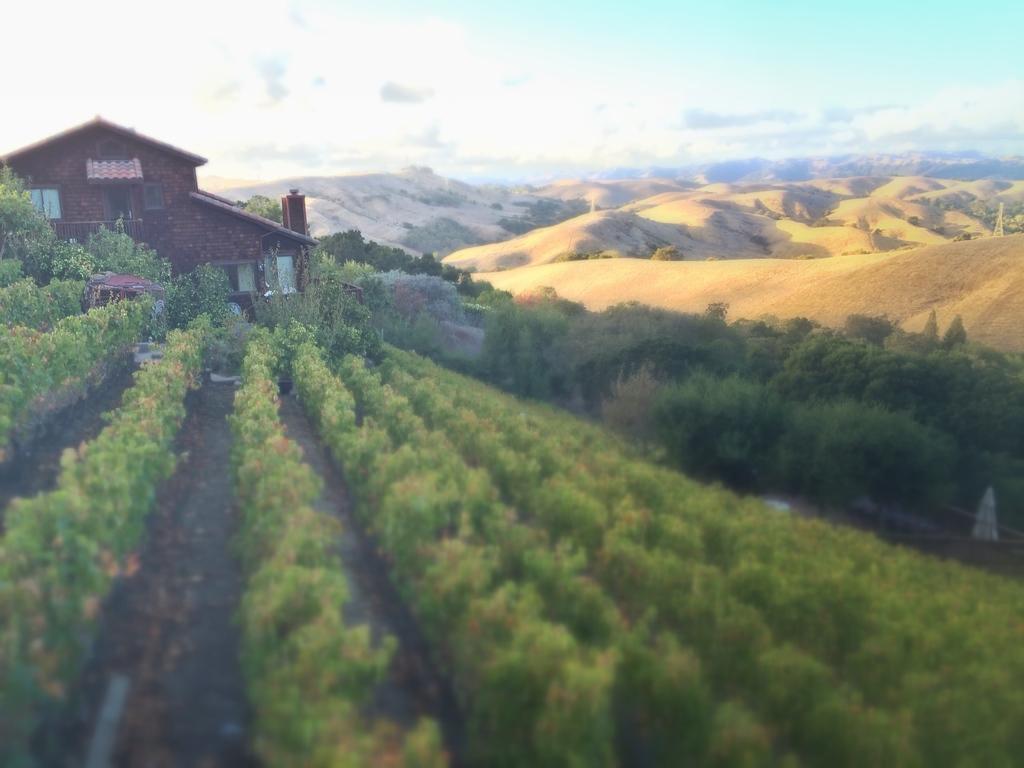In one or two sentences, can you explain what this image depicts? In this image there are plants, house, trees, hills, and in the background there is sky. 